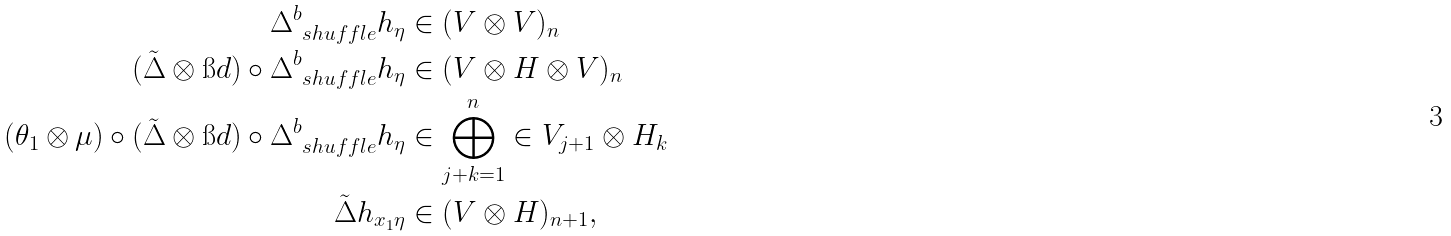<formula> <loc_0><loc_0><loc_500><loc_500>\Delta _ { \ s h u f f l e } ^ { b } h _ { \eta } & \in ( V \otimes V ) _ { n } \\ ( \tilde { \Delta } \otimes \i d ) \circ \Delta _ { \ s h u f f l e } ^ { b } h _ { \eta } & \in ( V \otimes H \otimes V ) _ { n } \\ ( \theta _ { 1 } \otimes \mu ) \circ ( \tilde { \Delta } \otimes \i d ) \circ \Delta _ { \ s h u f f l e } ^ { b } h _ { \eta } & \in \bigoplus _ { j + k = 1 } ^ { n } \in V _ { j + 1 } \otimes H _ { k } \\ \tilde { \Delta } h _ { x _ { 1 } \eta } & \in ( V \otimes H ) _ { n + 1 } , \\</formula> 